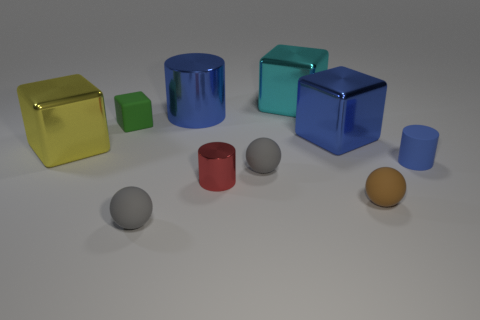Do the blue cylinder in front of the blue shiny cylinder and the cyan shiny object have the same size?
Keep it short and to the point. No. There is a tiny rubber thing that is the same color as the big shiny cylinder; what shape is it?
Provide a succinct answer. Cylinder. How many other big objects have the same material as the yellow thing?
Offer a very short reply. 3. What is the material of the small ball on the left side of the large blue thing that is to the left of the small cylinder that is in front of the blue matte object?
Give a very brief answer. Rubber. There is a small object that is behind the blue cylinder in front of the large yellow block; what is its color?
Offer a very short reply. Green. The cube that is the same size as the matte cylinder is what color?
Ensure brevity in your answer.  Green. What number of small objects are brown balls or rubber objects?
Make the answer very short. 5. Are there more large yellow shiny cubes right of the small rubber cylinder than big cyan metallic things behind the cyan cube?
Provide a short and direct response. No. The block that is the same color as the large metal cylinder is what size?
Your response must be concise. Large. What number of other things are there of the same size as the cyan object?
Offer a very short reply. 3. 